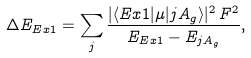Convert formula to latex. <formula><loc_0><loc_0><loc_500><loc_500>\Delta E _ { E x 1 } = \sum _ { j } \frac { | \langle E x 1 | \mu | j A _ { g } \rangle | ^ { 2 } \, F ^ { 2 } } { E _ { E x 1 } - E _ { j A _ { g } } } ,</formula> 